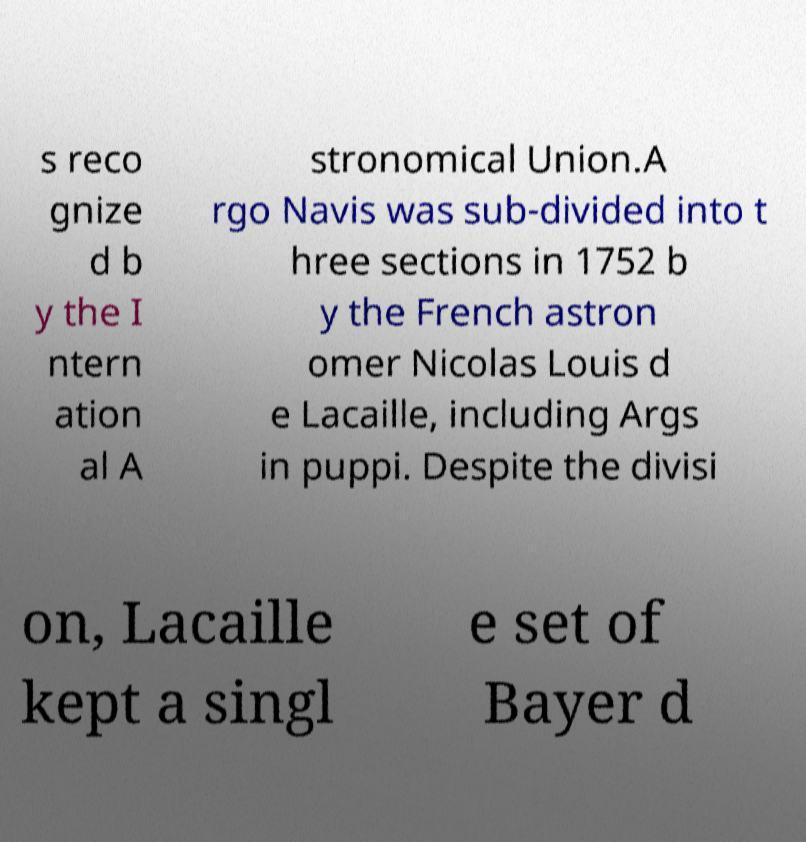What messages or text are displayed in this image? I need them in a readable, typed format. s reco gnize d b y the I ntern ation al A stronomical Union.A rgo Navis was sub-divided into t hree sections in 1752 b y the French astron omer Nicolas Louis d e Lacaille, including Args in puppi. Despite the divisi on, Lacaille kept a singl e set of Bayer d 